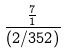Convert formula to latex. <formula><loc_0><loc_0><loc_500><loc_500>\frac { \frac { 7 } { 1 } } { ( 2 / 3 5 2 ) }</formula> 